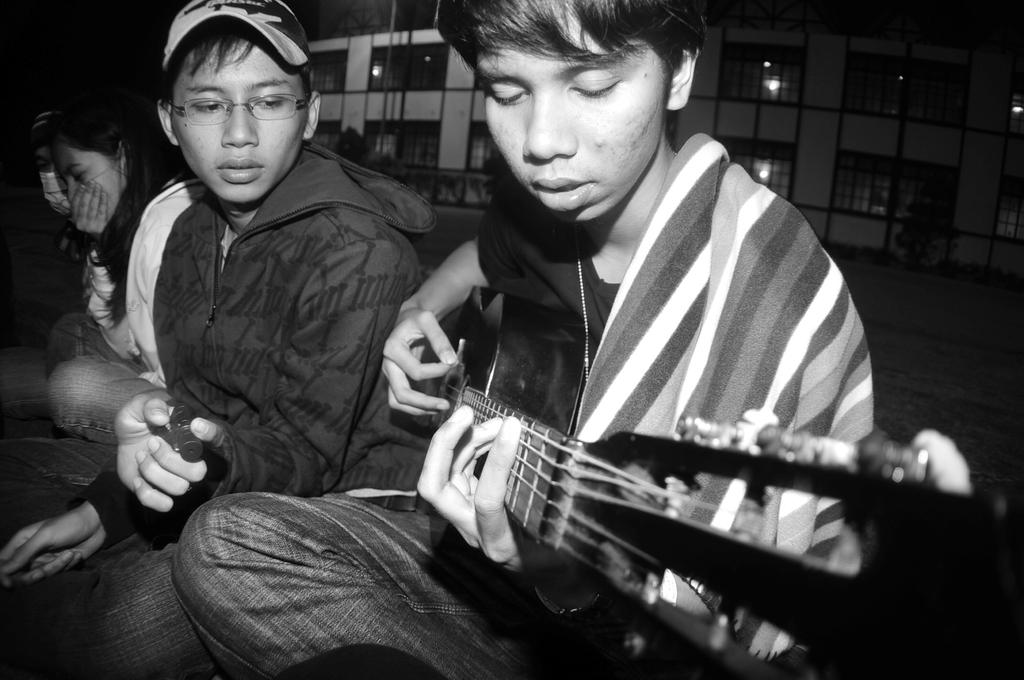What is the man in the image doing? The man in the image is sitting and playing a guitar. Are there any other people in the image? Yes, there are other men in the image. Can you describe the woman in the image? The woman is sitting beside the man playing the guitar. What can be seen in the background of the image? There is a building in the background of the image. What is the profit margin of the guitar in the image? The image does not provide information about the profit margin of the guitar, as it is focused on the people and their actions. 